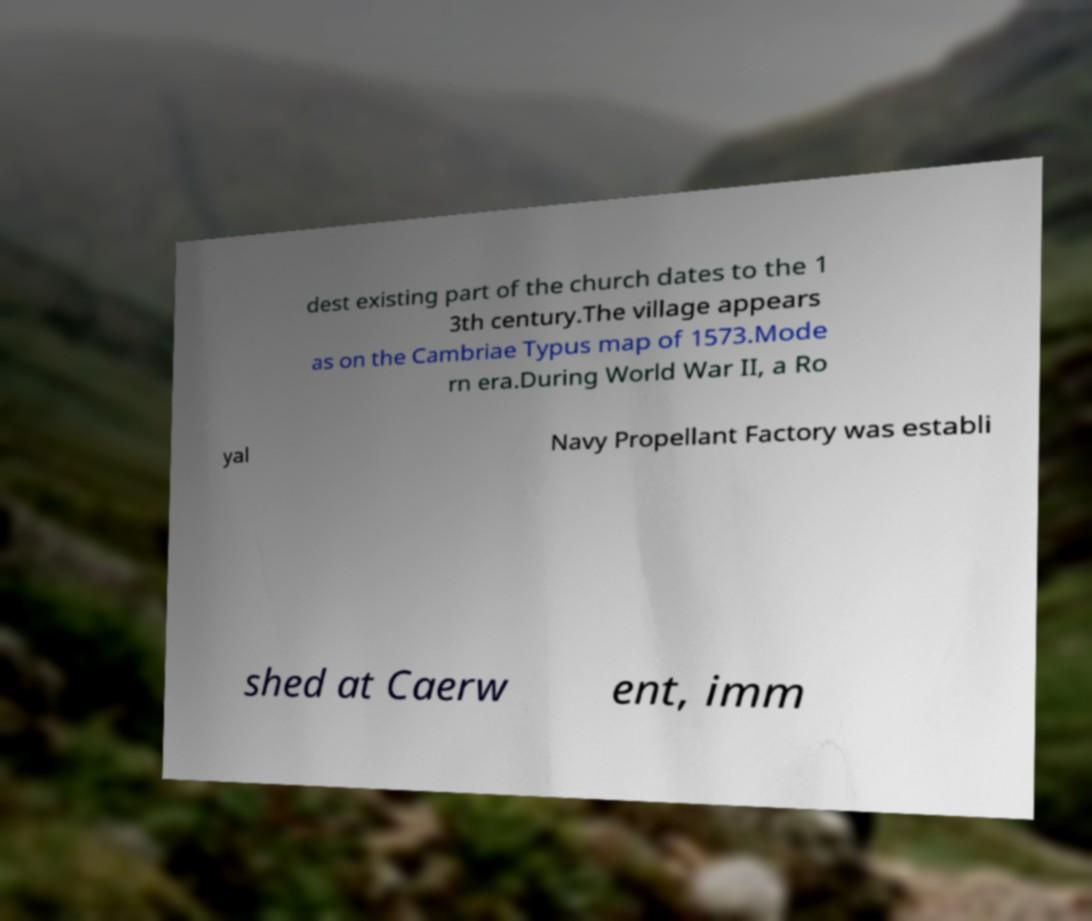Please identify and transcribe the text found in this image. dest existing part of the church dates to the 1 3th century.The village appears as on the Cambriae Typus map of 1573.Mode rn era.During World War II, a Ro yal Navy Propellant Factory was establi shed at Caerw ent, imm 